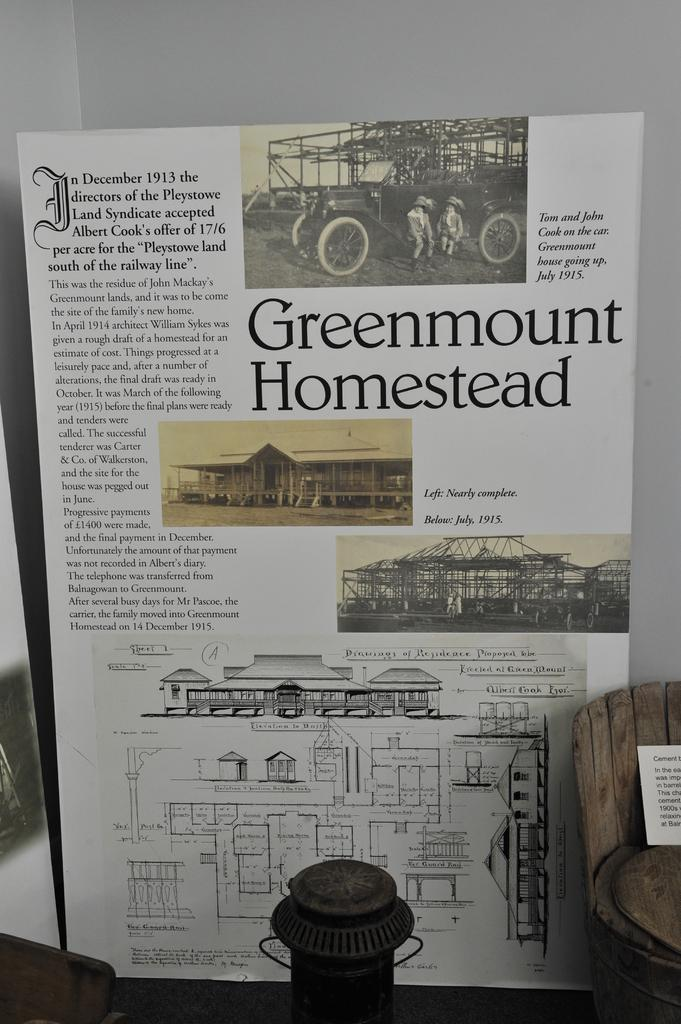What is the main subject in the center of the image? There is a poster in the center of the image. What type of objects can be seen at the bottom of the image? There are wooden objects at the bottom of the image. What is located on the left side of the image? There is an object on the left side of the image. How is the wall at the top of the image colored? The wall at the top of the image is painted white. Can you see any hair on the poster in the image? There is no hair present on the poster in the image. 